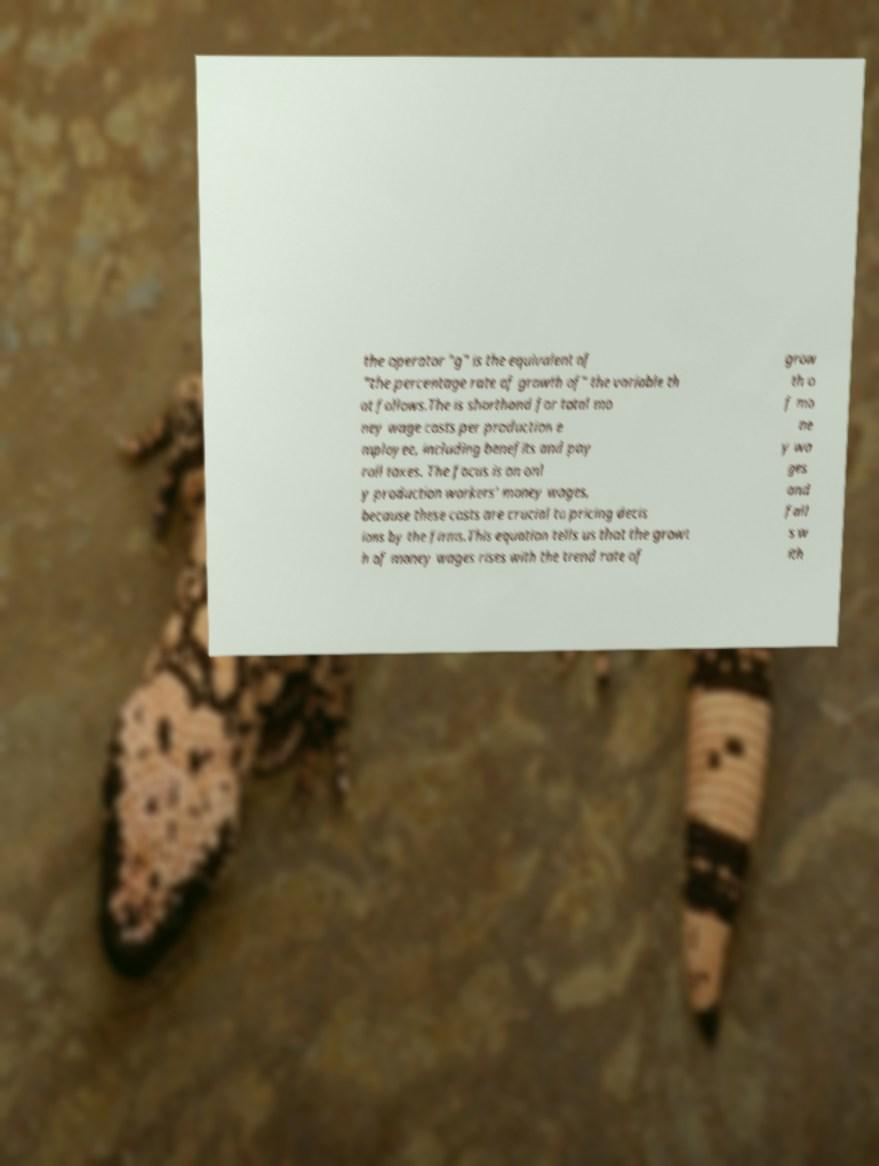Can you read and provide the text displayed in the image?This photo seems to have some interesting text. Can you extract and type it out for me? the operator "g" is the equivalent of "the percentage rate of growth of" the variable th at follows.The is shorthand for total mo ney wage costs per production e mployee, including benefits and pay roll taxes. The focus is on onl y production workers' money wages, because these costs are crucial to pricing decis ions by the firms.This equation tells us that the growt h of money wages rises with the trend rate of grow th o f mo ne y wa ges and fall s w ith 